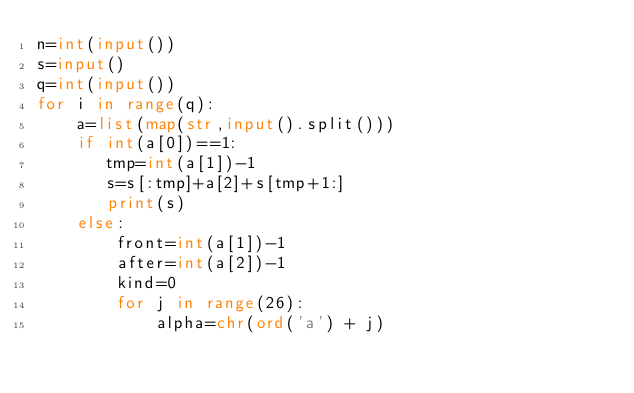Convert code to text. <code><loc_0><loc_0><loc_500><loc_500><_Python_>n=int(input())
s=input()
q=int(input())
for i in range(q):
    a=list(map(str,input().split()))
    if int(a[0])==1:
       tmp=int(a[1])-1
       s=s[:tmp]+a[2]+s[tmp+1:]
       print(s)
    else:
        front=int(a[1])-1
        after=int(a[2])-1
        kind=0
        for j in range(26):
            alpha=chr(ord('a') + j)
            
</code> 